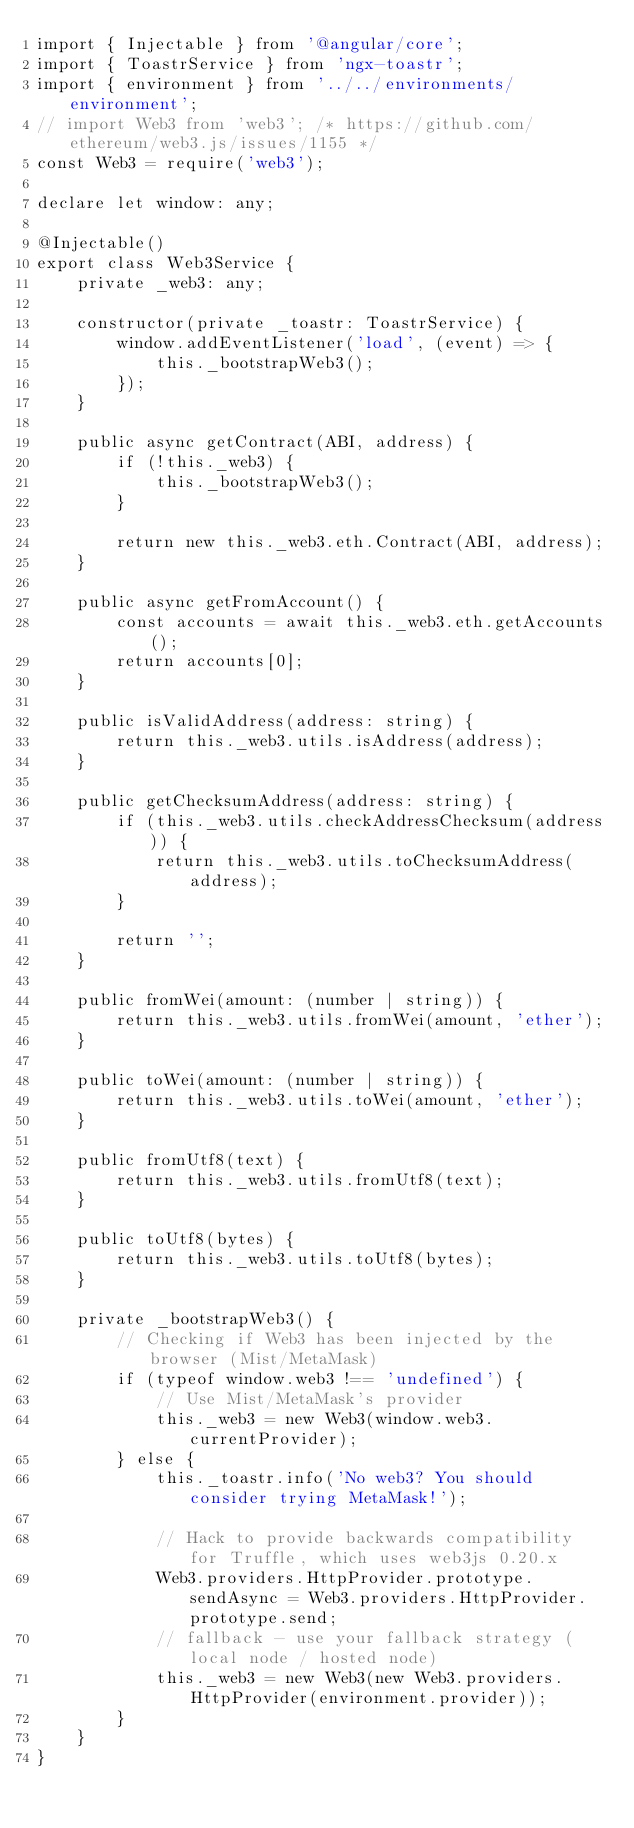Convert code to text. <code><loc_0><loc_0><loc_500><loc_500><_TypeScript_>import { Injectable } from '@angular/core';
import { ToastrService } from 'ngx-toastr';
import { environment } from '../../environments/environment';
// import Web3 from 'web3'; /* https://github.com/ethereum/web3.js/issues/1155 */
const Web3 = require('web3');

declare let window: any;

@Injectable()
export class Web3Service {
	private _web3: any;

	constructor(private _toastr: ToastrService) {
		window.addEventListener('load', (event) => {
			this._bootstrapWeb3();
		});
	}

	public async getContract(ABI, address) {
		if (!this._web3) {
			this._bootstrapWeb3();
		}

		return new this._web3.eth.Contract(ABI, address);
	}

	public async getFromAccount() {
		const accounts = await this._web3.eth.getAccounts();
		return accounts[0];
	}

	public isValidAddress(address: string) {
		return this._web3.utils.isAddress(address);
	}

	public getChecksumAddress(address: string) {
		if (this._web3.utils.checkAddressChecksum(address)) {
			return this._web3.utils.toChecksumAddress(address);
		}

		return '';
	}

	public fromWei(amount: (number | string)) {
		return this._web3.utils.fromWei(amount, 'ether');
	}

	public toWei(amount: (number | string)) {
		return this._web3.utils.toWei(amount, 'ether');
	}

	public fromUtf8(text) {
		return this._web3.utils.fromUtf8(text);
	}

	public toUtf8(bytes) {
		return this._web3.utils.toUtf8(bytes);
	}

	private _bootstrapWeb3() {
		// Checking if Web3 has been injected by the browser (Mist/MetaMask)
		if (typeof window.web3 !== 'undefined') {
			// Use Mist/MetaMask's provider
			this._web3 = new Web3(window.web3.currentProvider);
		} else {
			this._toastr.info('No web3? You should consider trying MetaMask!');

			// Hack to provide backwards compatibility for Truffle, which uses web3js 0.20.x
			Web3.providers.HttpProvider.prototype.sendAsync = Web3.providers.HttpProvider.prototype.send;
			// fallback - use your fallback strategy (local node / hosted node)
			this._web3 = new Web3(new Web3.providers.HttpProvider(environment.provider));
		}
	}
}
</code> 